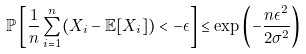<formula> <loc_0><loc_0><loc_500><loc_500>\mathbb { P } \left [ \frac { 1 } { n } \sum _ { i = 1 } ^ { n } ( X _ { i } - \mathbb { E } [ X _ { i } ] ) < - \epsilon \right ] \leq \exp \left ( - \frac { n \epsilon ^ { 2 } } { 2 \sigma ^ { 2 } } \right )</formula> 